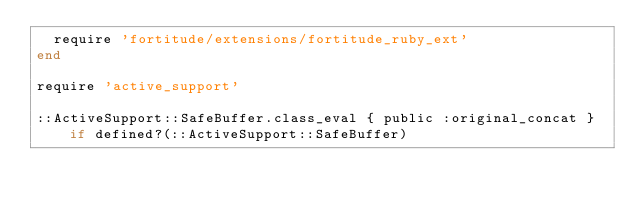Convert code to text. <code><loc_0><loc_0><loc_500><loc_500><_Ruby_>  require 'fortitude/extensions/fortitude_ruby_ext'
end

require 'active_support'

::ActiveSupport::SafeBuffer.class_eval { public :original_concat } if defined?(::ActiveSupport::SafeBuffer)
</code> 